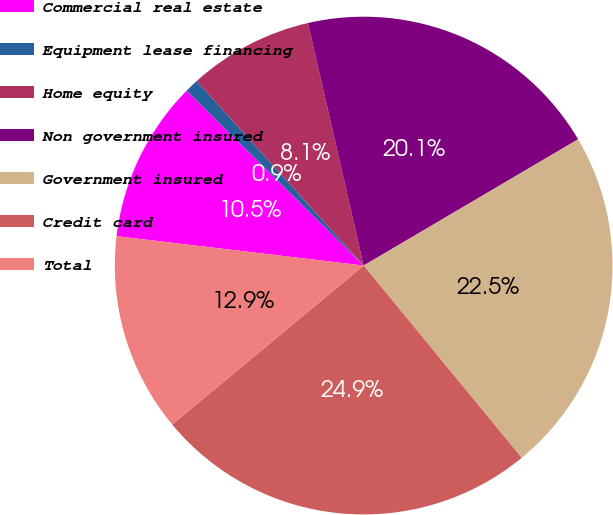<chart> <loc_0><loc_0><loc_500><loc_500><pie_chart><fcel>Commercial real estate<fcel>Equipment lease financing<fcel>Home equity<fcel>Non government insured<fcel>Government insured<fcel>Credit card<fcel>Total<nl><fcel>10.51%<fcel>0.9%<fcel>8.11%<fcel>20.12%<fcel>22.52%<fcel>24.92%<fcel>12.91%<nl></chart> 